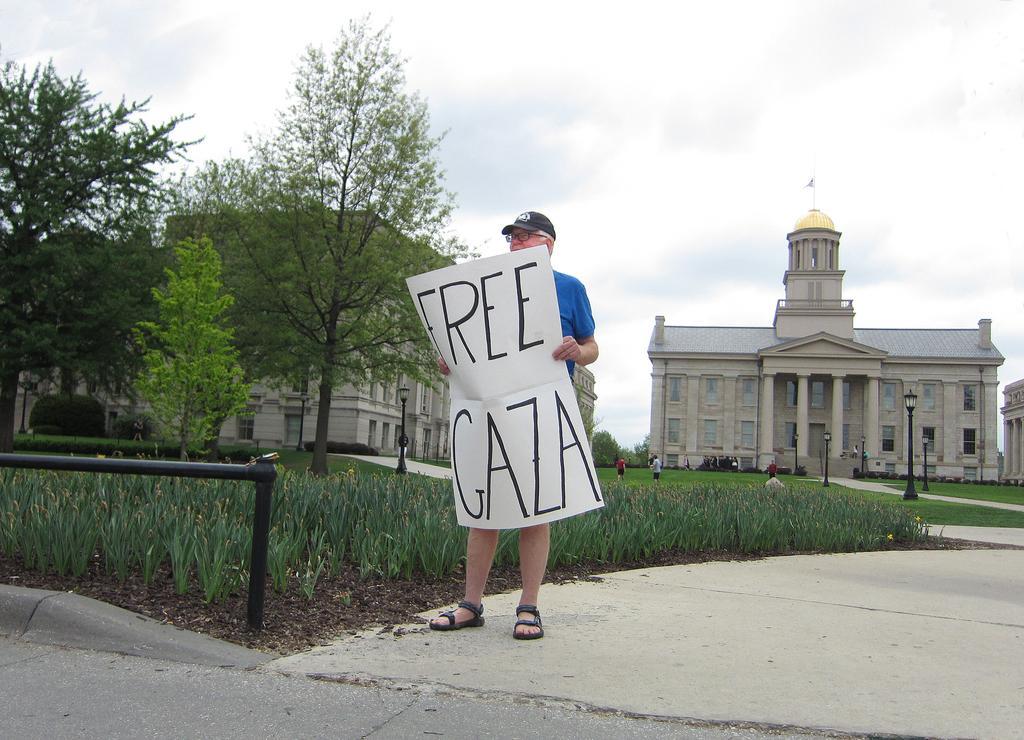Please provide a concise description of this image. In this image there is a person standing and holding a banner with some text on it, beside him there is a railing, grass, trees, buildings, in front of the buildings there are few people walking on the grass and there are few lamps. In the background there is the sky. 